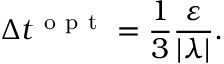Convert formula to latex. <formula><loc_0><loc_0><loc_500><loc_500>\Delta t ^ { o p t } = \frac { 1 } { 3 } \frac { \varepsilon } { | \lambda | } .</formula> 